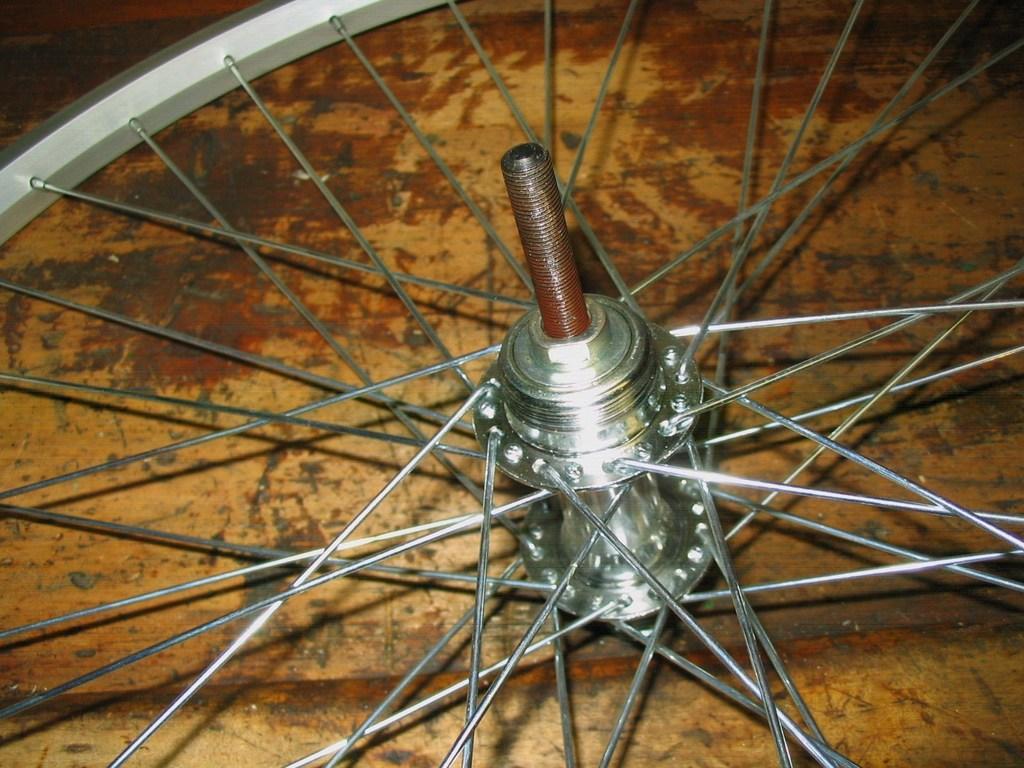In one or two sentences, can you explain what this image depicts? In this picture we can see a wheel of a bicycle on the platform. 